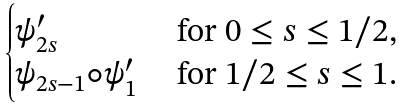<formula> <loc_0><loc_0><loc_500><loc_500>\begin{cases} \psi ^ { \prime } _ { 2 s } & \text { for $0\leq s\leq 1/2$} , \\ \psi _ { 2 s - 1 } \circ \psi ^ { \prime } _ { 1 } & \text { for $1/2\leq s\leq 1$} . \end{cases}</formula> 